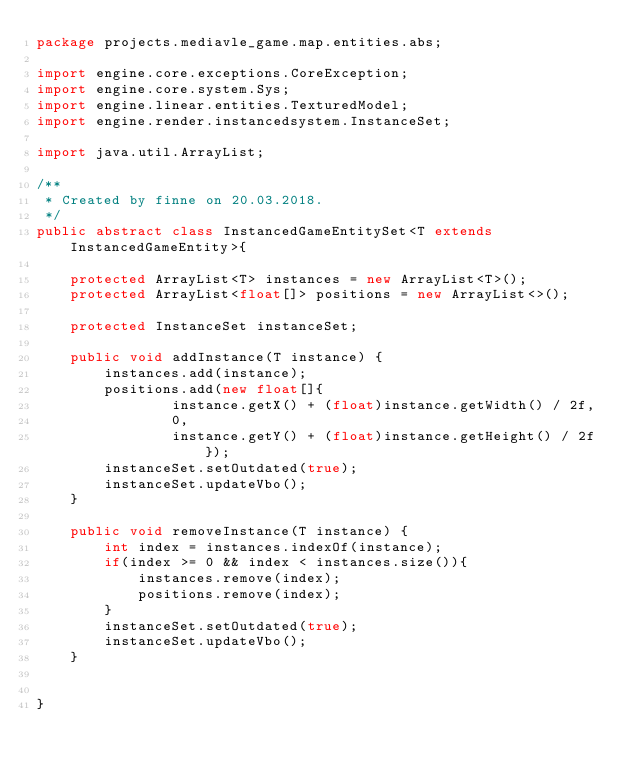Convert code to text. <code><loc_0><loc_0><loc_500><loc_500><_Java_>package projects.mediavle_game.map.entities.abs;

import engine.core.exceptions.CoreException;
import engine.core.system.Sys;
import engine.linear.entities.TexturedModel;
import engine.render.instancedsystem.InstanceSet;

import java.util.ArrayList;

/**
 * Created by finne on 20.03.2018.
 */
public abstract class InstancedGameEntitySet<T extends InstancedGameEntity>{

    protected ArrayList<T> instances = new ArrayList<T>();
    protected ArrayList<float[]> positions = new ArrayList<>();

    protected InstanceSet instanceSet;

    public void addInstance(T instance) {
        instances.add(instance);
        positions.add(new float[]{
                instance.getX() + (float)instance.getWidth() / 2f,
                0,
                instance.getY() + (float)instance.getHeight() / 2f});
        instanceSet.setOutdated(true);
        instanceSet.updateVbo();
    }

    public void removeInstance(T instance) {
        int index = instances.indexOf(instance);
        if(index >= 0 && index < instances.size()){
            instances.remove(index);
            positions.remove(index);
        }
        instanceSet.setOutdated(true);
        instanceSet.updateVbo();
    }


}
</code> 